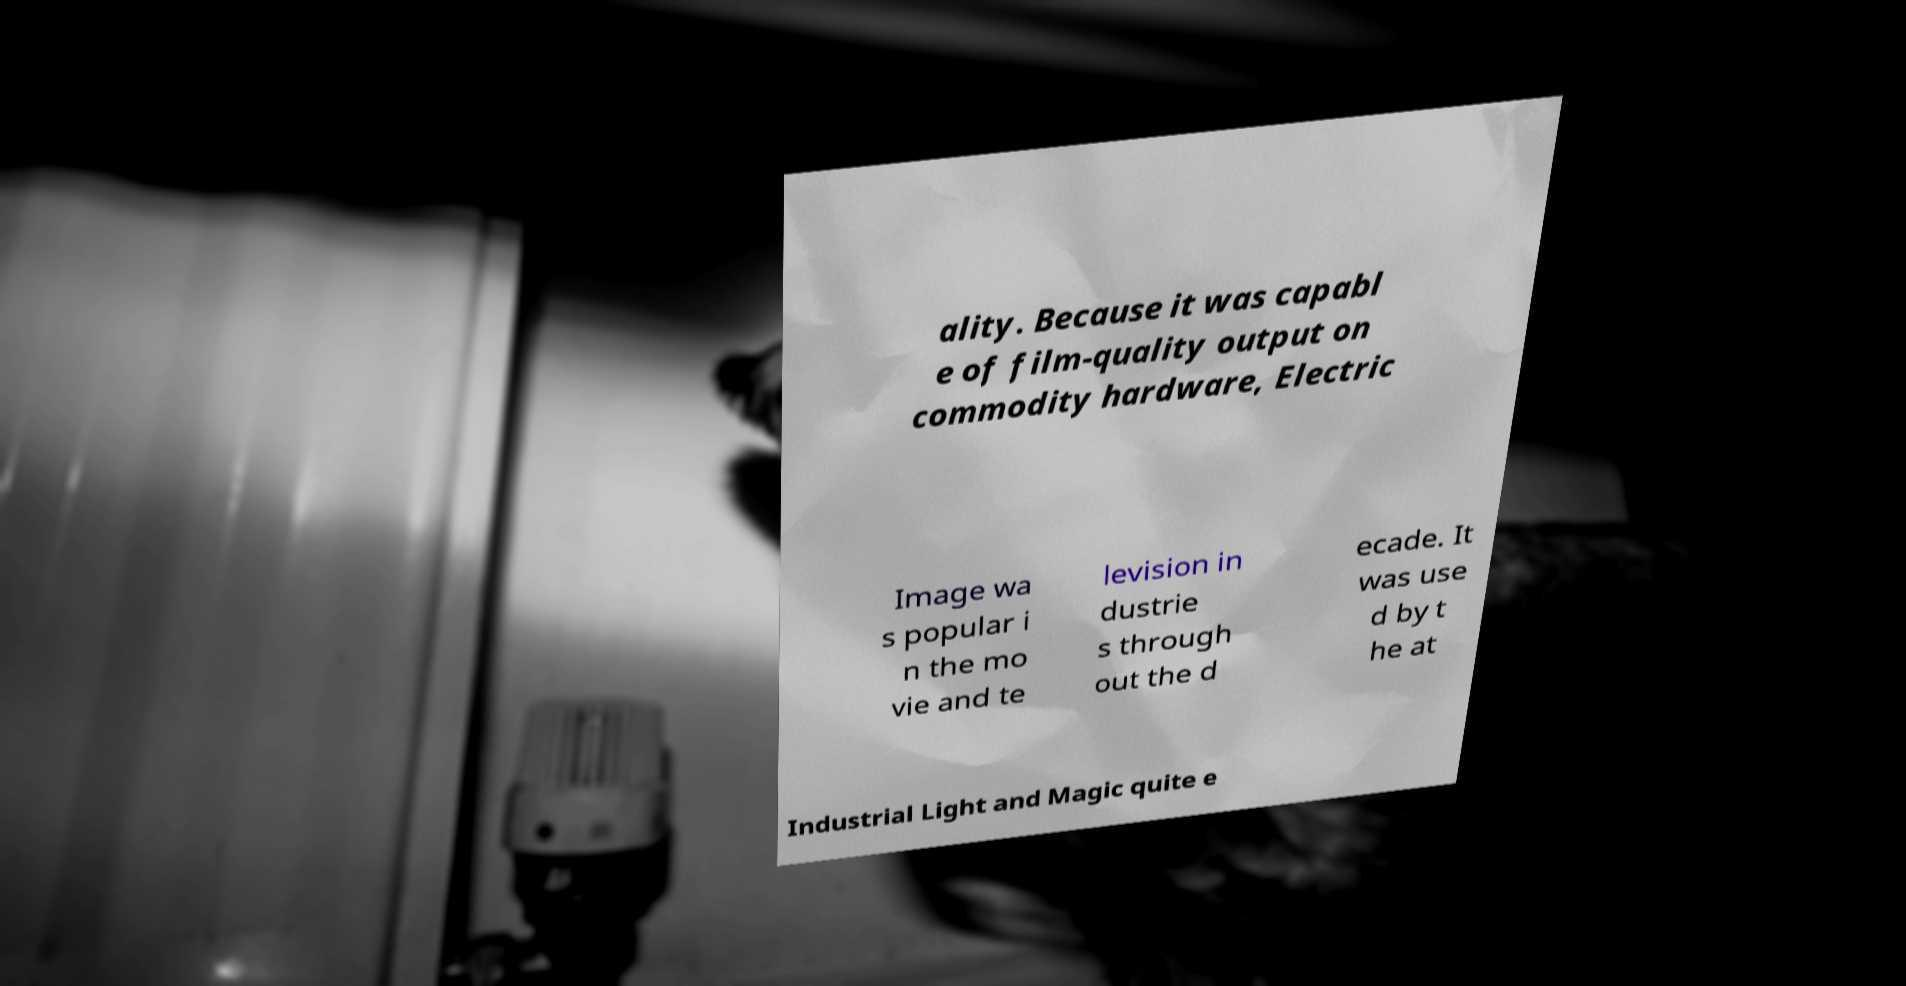There's text embedded in this image that I need extracted. Can you transcribe it verbatim? ality. Because it was capabl e of film-quality output on commodity hardware, Electric Image wa s popular i n the mo vie and te levision in dustrie s through out the d ecade. It was use d by t he at Industrial Light and Magic quite e 